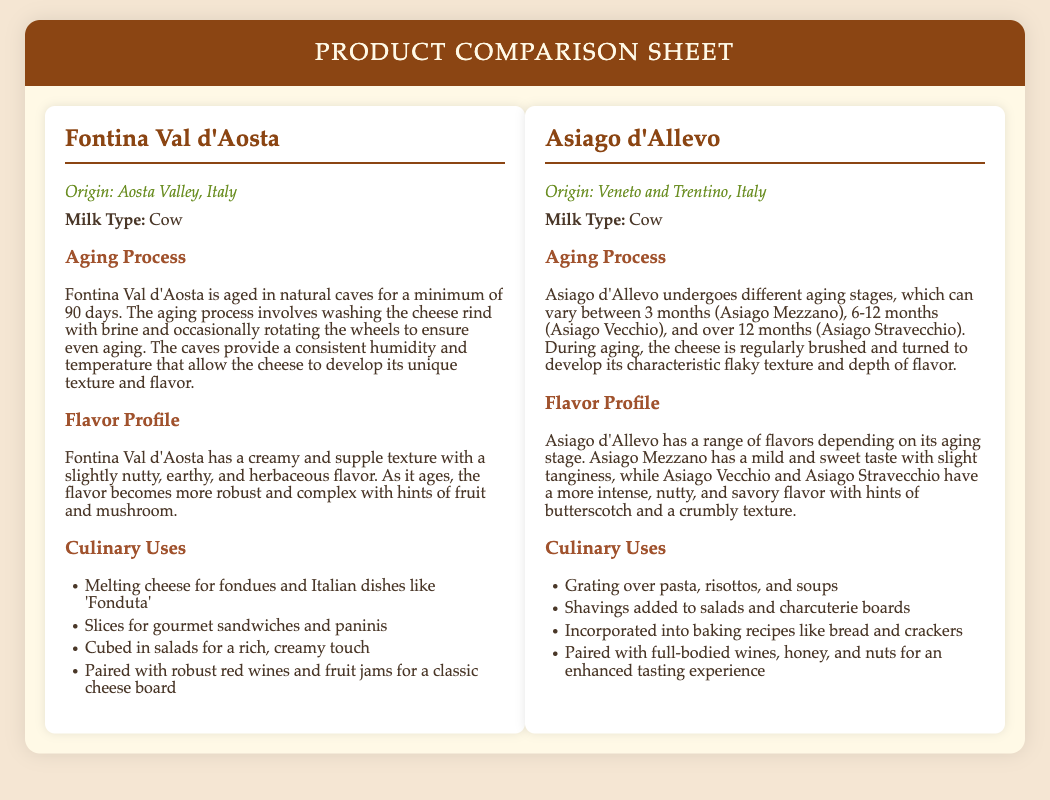What is the origin of Fontina Val d'Aosta? The origin is mentioned explicitly in the document, which states it is "Aosta Valley, Italy."
Answer: Aosta Valley, Italy What type of milk is used for Asiago d'Allevo? The document specifies the milk type used for Asiago d'Allevo as "Cow."
Answer: Cow How long is Fontina Val d'Aosta aged? The document notes that Fontina is aged for "a minimum of 90 days."
Answer: 90 days What flavor profile does Asiago Vecchio have? The document describes Asiago Vecchio as having "a more intense, nutty, and savory flavor."
Answer: Intense, nutty, and savory What culinary use is suggested for Fontina Val d'Aosta? The document lists multiple culinary uses, one of which is "Melting cheese for fondues."
Answer: Melting cheese for fondues Which cheese undergoes different aging stages? The document indicates that "Asiago d'Allevo undergoes different aging stages."
Answer: Asiago d'Allevo What is the aging range for Asiago d'Allevo? The document specifies aging can vary, with stages like "3 months (Asiago Mezzano), 6-12 months (Asiago Vecchio), and over 12 months (Asiago Stravecchio)."
Answer: 3 months to over 12 months What is the primary culinary use of Asiago d'Allevo? The document lists "Grating over pasta, risottos, and soups" as a primary culinary use.
Answer: Grating over pasta What is a key characteristic of the aging process for Fontina Val d'Aosta? The document mentions that the cheese rind is "washed with brine" during the aging process.
Answer: Washed with brine 